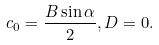Convert formula to latex. <formula><loc_0><loc_0><loc_500><loc_500>c _ { 0 } = \frac { B \sin \alpha } 2 , D = 0 .</formula> 